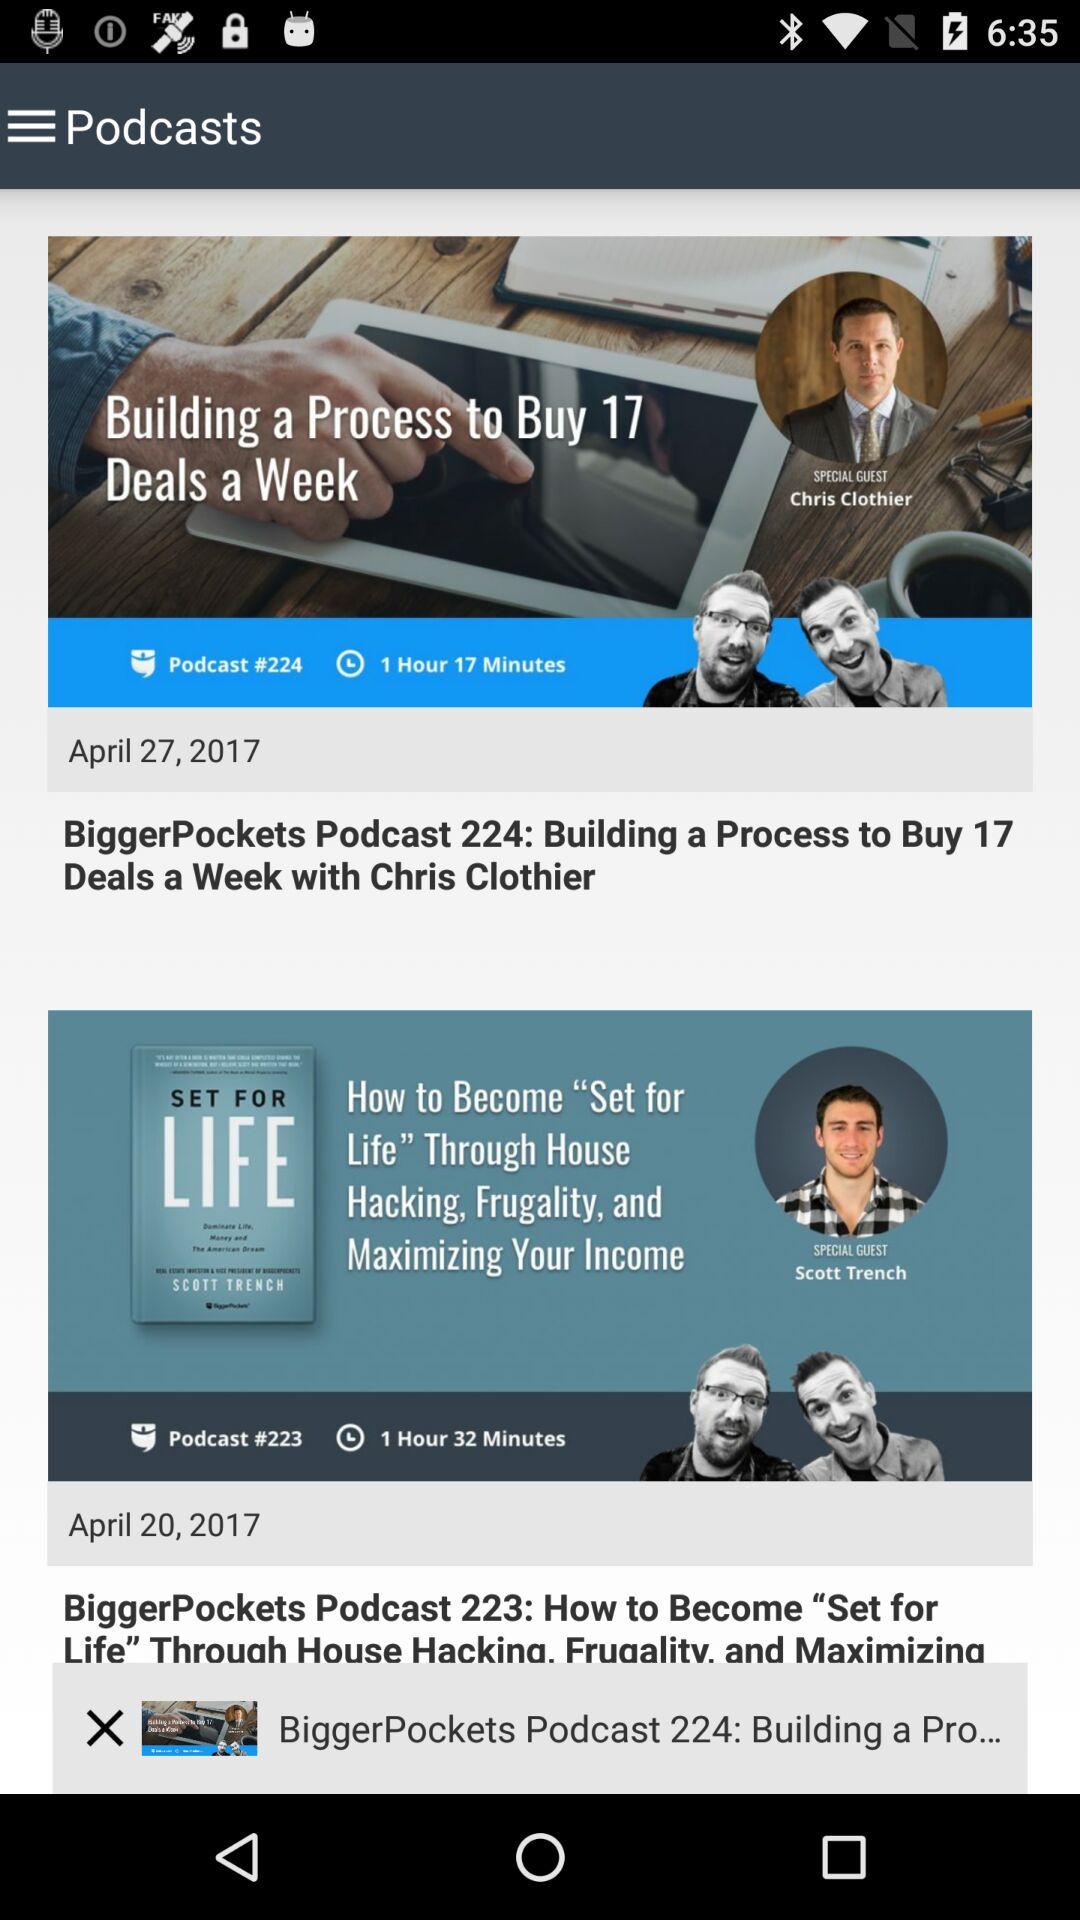What is the time duration of "BiggerPockets Podcast 224"? The time duration is 1 hour 17 minutes. 